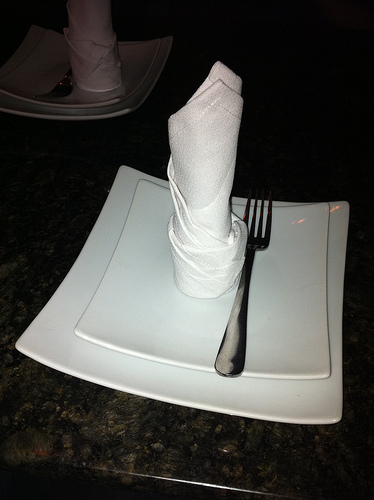<image>
Can you confirm if the fork is on the plate? Yes. Looking at the image, I can see the fork is positioned on top of the plate, with the plate providing support. Is there a napkin behind the plate? No. The napkin is not behind the plate. From this viewpoint, the napkin appears to be positioned elsewhere in the scene. Where is the fork in relation to the plate? Is it behind the plate? No. The fork is not behind the plate. From this viewpoint, the fork appears to be positioned elsewhere in the scene. 